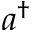Convert formula to latex. <formula><loc_0><loc_0><loc_500><loc_500>a ^ { \dagger }</formula> 